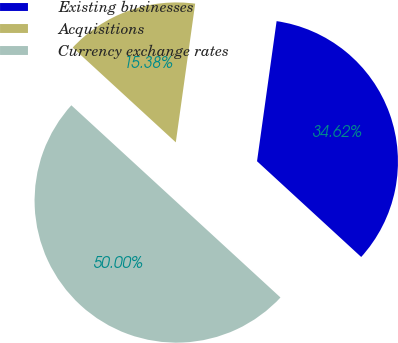Convert chart. <chart><loc_0><loc_0><loc_500><loc_500><pie_chart><fcel>Existing businesses<fcel>Acquisitions<fcel>Currency exchange rates<nl><fcel>34.62%<fcel>15.38%<fcel>50.0%<nl></chart> 